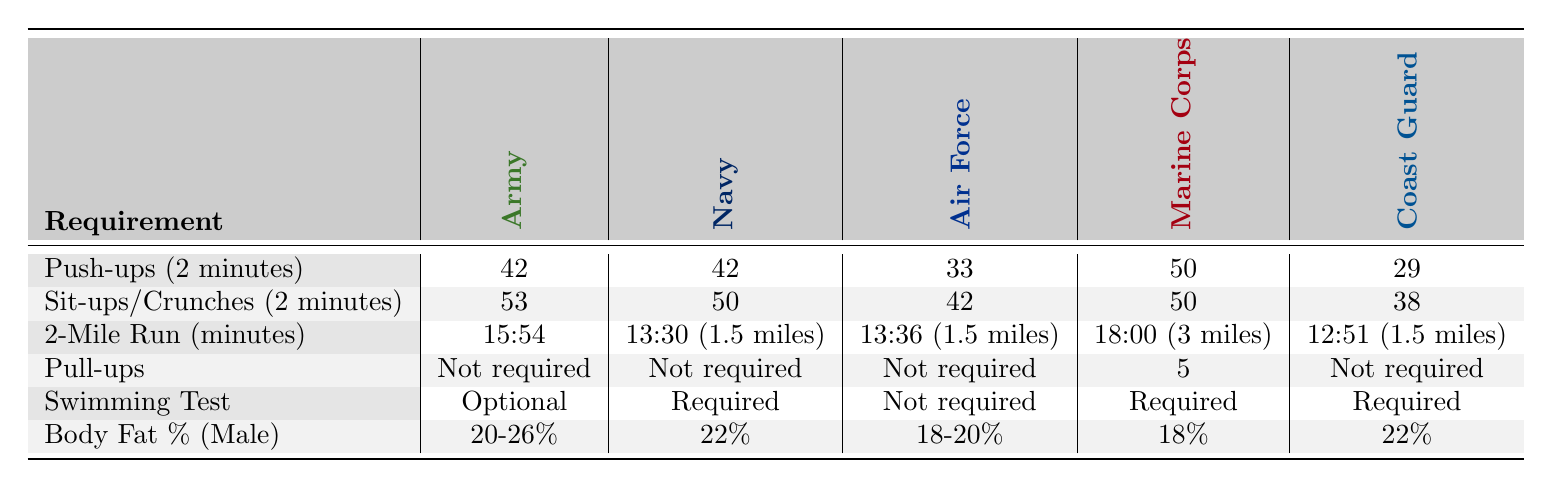What are the push-up requirements for the Marine Corps? The Marine Corps requires 50 push-ups in 2 minutes, which can be found directly under the "Push-ups (2 minutes)" category in the Marine Corps column.
Answer: 50 What is the body fat percentage requirement for the Army? The Army's body fat percentage requirement for males is between 20% to 26%, as indicated in the "Body Fat % (Male)" row under the Army column.
Answer: 20-26% Do the Navy and the Army have the same requirements for sit-ups? Yes, the Navy requires 50 sit-ups, while the Army requires 53 sit-ups, so they do not have the same requirement. The values can be compared directly from the table.
Answer: No Which branch has the highest number of required sit-ups? The Army has the highest requirement with 53 sit-ups in 2 minutes, which is the greatest value when comparing all branches at that row in the table.
Answer: Army What is the difference in the 2-mile run requirement between the Navy and the Coast Guard? The Navy's requirement is 13:30 for 1.5 miles, while the Coast Guard's is 12:51 for 1.5 miles. Since both are for the same distance, we need to convert the time into a comparable format. 13:30 is 810 seconds, and 12:51 is 771 seconds. The difference is 810 - 771 = 39 seconds.
Answer: 39 seconds How many branches require swimming tests? The table indicates that swimming tests are required for the Navy, Marine Corps, and Coast Guard, which totals 3 branches. This can be counted from the "Swimming Test" row by identifying how many entries are marked as "Required."
Answer: 3 Which branch has the most comprehensive physical fitness requirements based on the number of tests listed? Based on the table, both the Marine Corps and the Coast Guard have requirements for 5 categories, which is the maximum, indicating that these branches have the most comprehensive set of physical fitness requirements compared to others.
Answer: Marine Corps and Coast Guard What is the average number of push-ups required across all branches? The push-up requirements are 42 (Army) + 42 (Navy) + 33 (Air Force) + 50 (Marine Corps) + 29 (Coast Guard) = 226 total push-ups. There are 5 branches, so the average is 226 / 5 = 45.2.
Answer: 45.2 Is the pull-up requirement the same for all branches? No, the Marine Corps requires 5 pull-ups, while the other branches do not require any, as indicated by the "Not required" entries in their respective rows.
Answer: No 